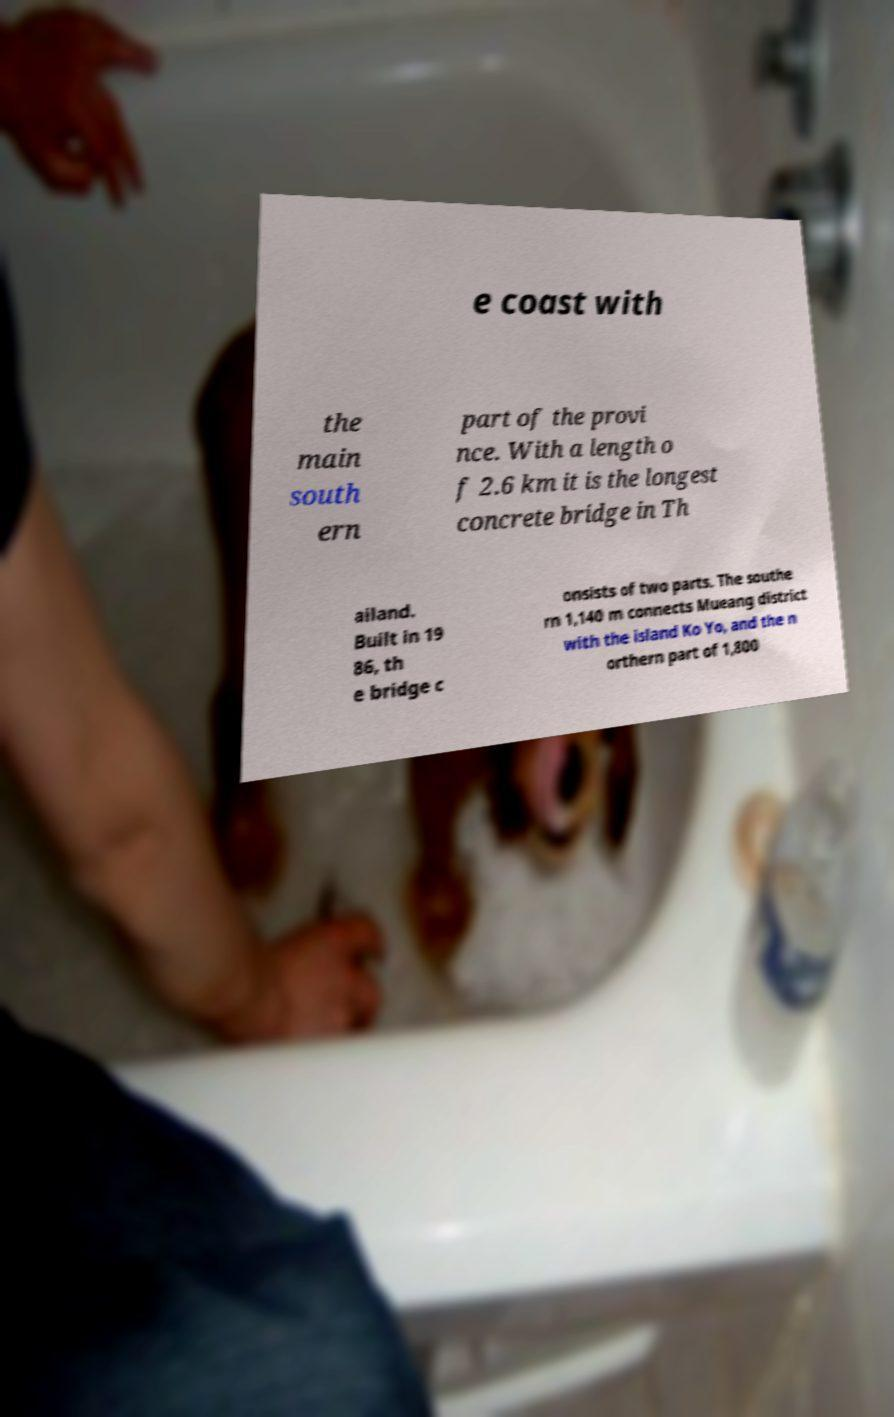I need the written content from this picture converted into text. Can you do that? e coast with the main south ern part of the provi nce. With a length o f 2.6 km it is the longest concrete bridge in Th ailand. Built in 19 86, th e bridge c onsists of two parts. The southe rn 1,140 m connects Mueang district with the island Ko Yo, and the n orthern part of 1,800 